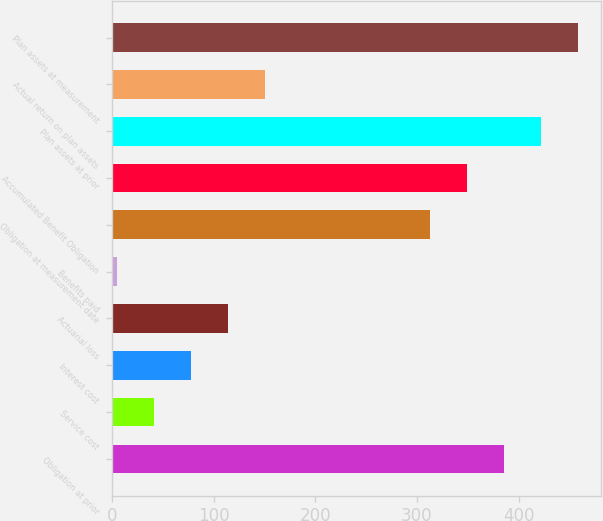<chart> <loc_0><loc_0><loc_500><loc_500><bar_chart><fcel>Obligation at prior<fcel>Service cost<fcel>Interest cost<fcel>Actuarial loss<fcel>Benefits paid<fcel>Obligation at measurement date<fcel>Accumulated Benefit Obligation<fcel>Plan assets at prior<fcel>Actual return on plan assets<fcel>Plan assets at measurement<nl><fcel>385.6<fcel>41.3<fcel>77.6<fcel>113.9<fcel>5<fcel>313<fcel>349.3<fcel>421.9<fcel>150.2<fcel>458.2<nl></chart> 